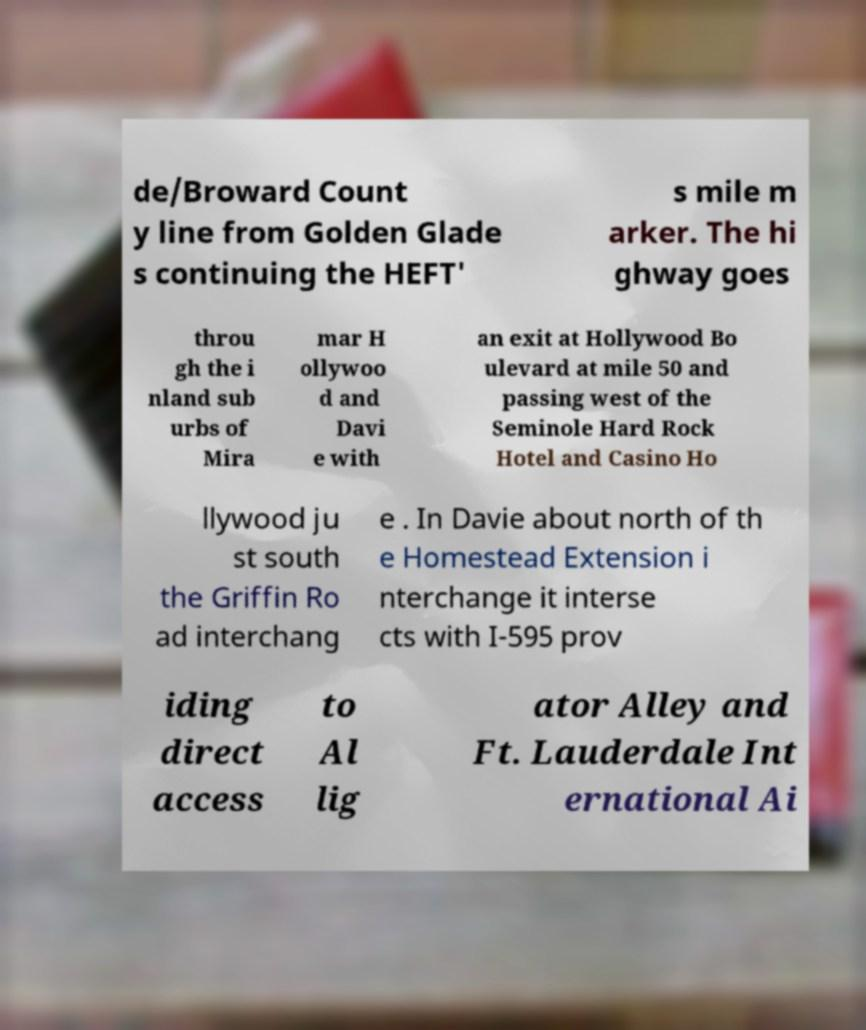Can you accurately transcribe the text from the provided image for me? de/Broward Count y line from Golden Glade s continuing the HEFT' s mile m arker. The hi ghway goes throu gh the i nland sub urbs of Mira mar H ollywoo d and Davi e with an exit at Hollywood Bo ulevard at mile 50 and passing west of the Seminole Hard Rock Hotel and Casino Ho llywood ju st south the Griffin Ro ad interchang e . In Davie about north of th e Homestead Extension i nterchange it interse cts with I-595 prov iding direct access to Al lig ator Alley and Ft. Lauderdale Int ernational Ai 